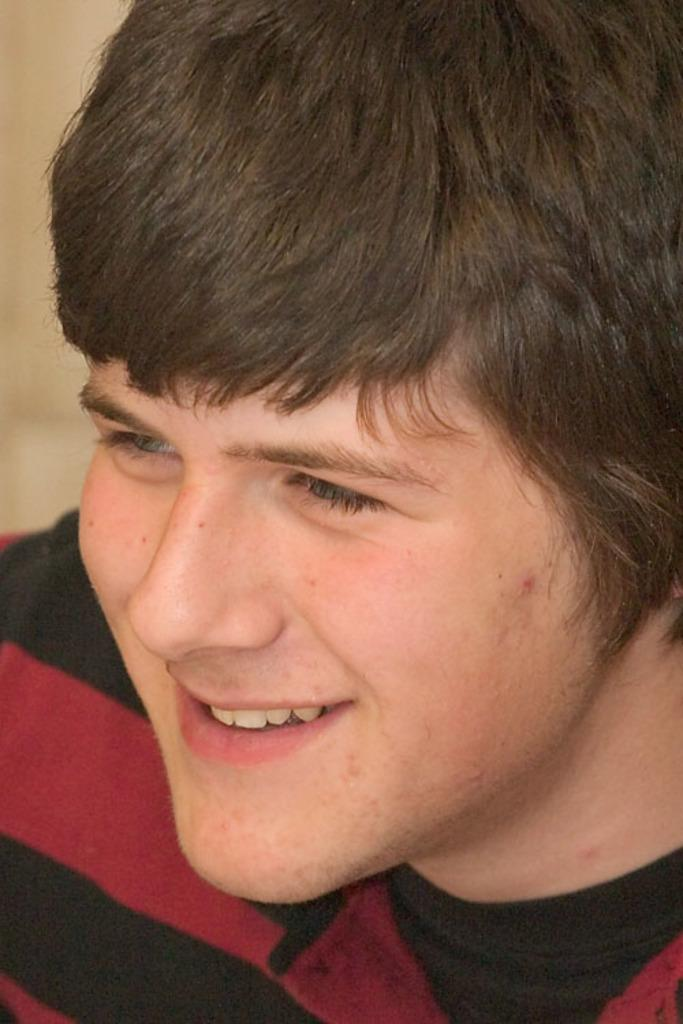What is present in the image? There is a person in the image. Can you describe the person's attire? The person is wearing a dress. How many children are riding the bike in the image? There is no bike or children present in the image. What type of thing is the person holding in the image? The provided facts do not mention any object being held by the person, so we cannot determine what type of thing they might be holding. 